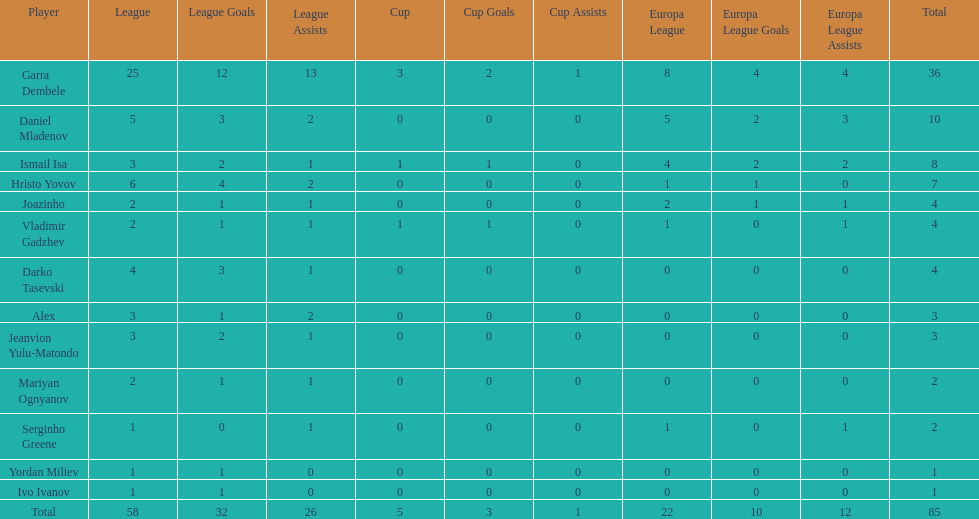How many of the players did not score any goals in the cup? 10. 